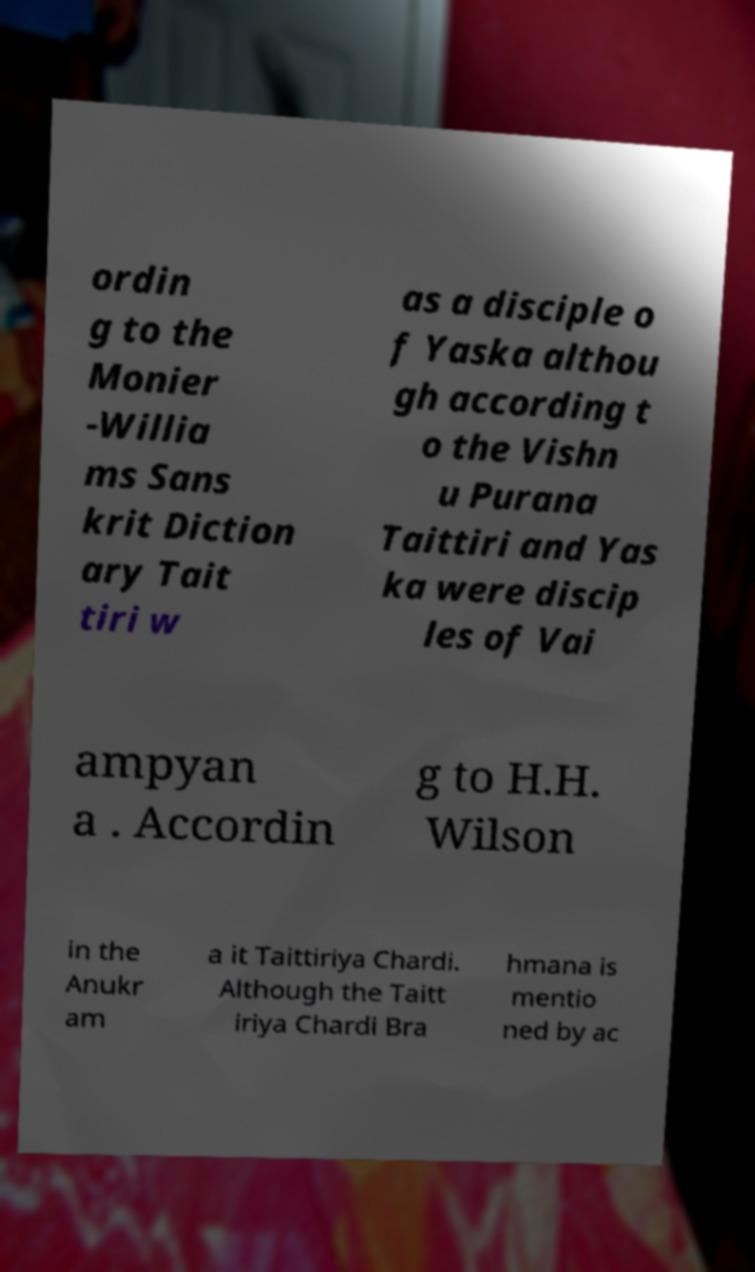What messages or text are displayed in this image? I need them in a readable, typed format. ordin g to the Monier -Willia ms Sans krit Diction ary Tait tiri w as a disciple o f Yaska althou gh according t o the Vishn u Purana Taittiri and Yas ka were discip les of Vai ampyan a . Accordin g to H.H. Wilson in the Anukr am a it Taittiriya Chardi. Although the Taitt iriya Chardi Bra hmana is mentio ned by ac 